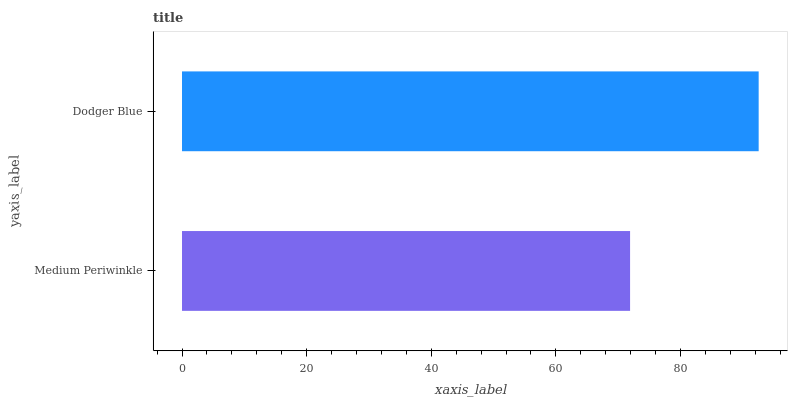Is Medium Periwinkle the minimum?
Answer yes or no. Yes. Is Dodger Blue the maximum?
Answer yes or no. Yes. Is Dodger Blue the minimum?
Answer yes or no. No. Is Dodger Blue greater than Medium Periwinkle?
Answer yes or no. Yes. Is Medium Periwinkle less than Dodger Blue?
Answer yes or no. Yes. Is Medium Periwinkle greater than Dodger Blue?
Answer yes or no. No. Is Dodger Blue less than Medium Periwinkle?
Answer yes or no. No. Is Dodger Blue the high median?
Answer yes or no. Yes. Is Medium Periwinkle the low median?
Answer yes or no. Yes. Is Medium Periwinkle the high median?
Answer yes or no. No. Is Dodger Blue the low median?
Answer yes or no. No. 